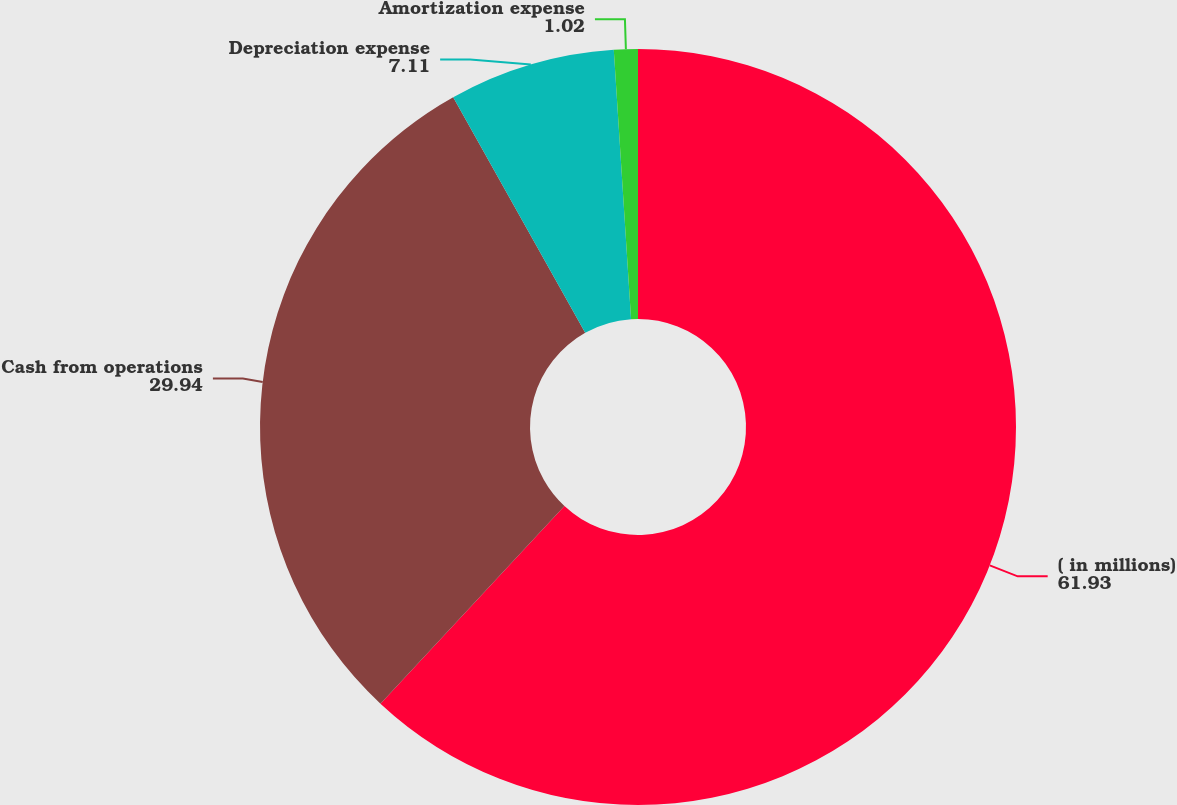<chart> <loc_0><loc_0><loc_500><loc_500><pie_chart><fcel>( in millions)<fcel>Cash from operations<fcel>Depreciation expense<fcel>Amortization expense<nl><fcel>61.93%<fcel>29.94%<fcel>7.11%<fcel>1.02%<nl></chart> 